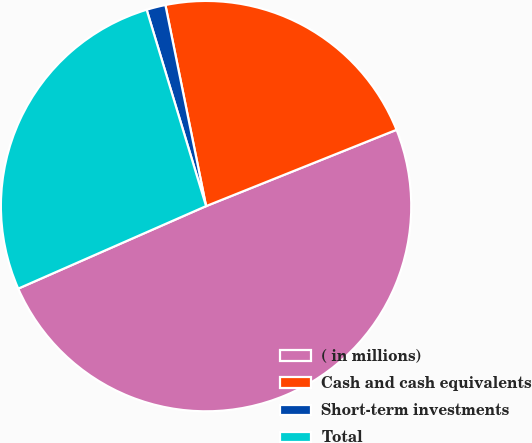Convert chart. <chart><loc_0><loc_0><loc_500><loc_500><pie_chart><fcel>( in millions)<fcel>Cash and cash equivalents<fcel>Short-term investments<fcel>Total<nl><fcel>49.48%<fcel>22.11%<fcel>1.5%<fcel>26.91%<nl></chart> 